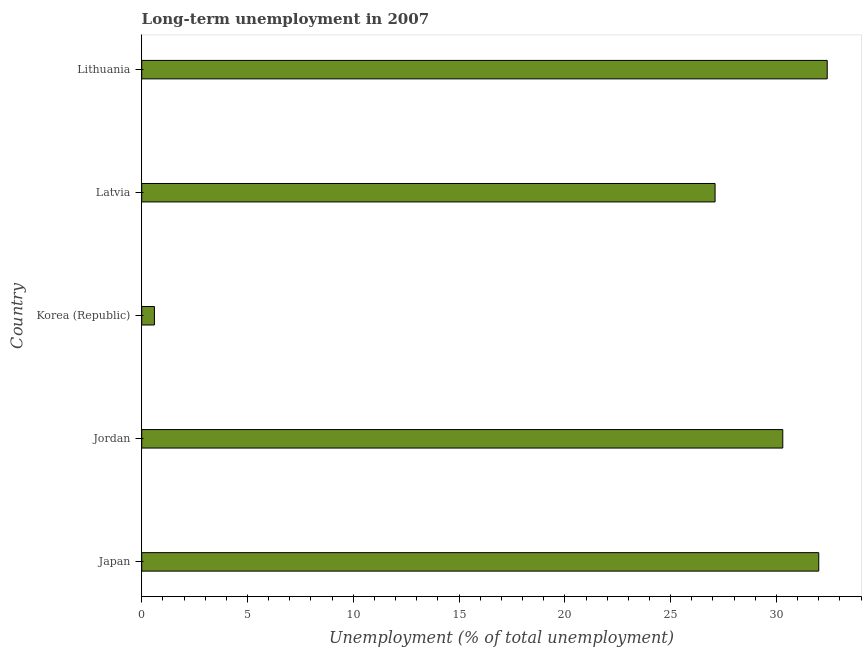Does the graph contain any zero values?
Offer a very short reply. No. Does the graph contain grids?
Ensure brevity in your answer.  No. What is the title of the graph?
Keep it short and to the point. Long-term unemployment in 2007. What is the label or title of the X-axis?
Give a very brief answer. Unemployment (% of total unemployment). What is the label or title of the Y-axis?
Your response must be concise. Country. What is the long-term unemployment in Lithuania?
Offer a terse response. 32.4. Across all countries, what is the maximum long-term unemployment?
Make the answer very short. 32.4. Across all countries, what is the minimum long-term unemployment?
Your answer should be very brief. 0.6. In which country was the long-term unemployment maximum?
Keep it short and to the point. Lithuania. In which country was the long-term unemployment minimum?
Provide a short and direct response. Korea (Republic). What is the sum of the long-term unemployment?
Provide a short and direct response. 122.4. What is the difference between the long-term unemployment in Jordan and Latvia?
Provide a short and direct response. 3.2. What is the average long-term unemployment per country?
Provide a short and direct response. 24.48. What is the median long-term unemployment?
Provide a short and direct response. 30.3. In how many countries, is the long-term unemployment greater than 31 %?
Your response must be concise. 2. What is the ratio of the long-term unemployment in Jordan to that in Latvia?
Give a very brief answer. 1.12. Is the difference between the long-term unemployment in Japan and Lithuania greater than the difference between any two countries?
Make the answer very short. No. Is the sum of the long-term unemployment in Japan and Lithuania greater than the maximum long-term unemployment across all countries?
Offer a very short reply. Yes. What is the difference between the highest and the lowest long-term unemployment?
Your answer should be very brief. 31.8. In how many countries, is the long-term unemployment greater than the average long-term unemployment taken over all countries?
Keep it short and to the point. 4. How many bars are there?
Make the answer very short. 5. Are the values on the major ticks of X-axis written in scientific E-notation?
Keep it short and to the point. No. What is the Unemployment (% of total unemployment) in Japan?
Make the answer very short. 32. What is the Unemployment (% of total unemployment) of Jordan?
Ensure brevity in your answer.  30.3. What is the Unemployment (% of total unemployment) in Korea (Republic)?
Give a very brief answer. 0.6. What is the Unemployment (% of total unemployment) in Latvia?
Offer a very short reply. 27.1. What is the Unemployment (% of total unemployment) in Lithuania?
Keep it short and to the point. 32.4. What is the difference between the Unemployment (% of total unemployment) in Japan and Jordan?
Your answer should be compact. 1.7. What is the difference between the Unemployment (% of total unemployment) in Japan and Korea (Republic)?
Your answer should be very brief. 31.4. What is the difference between the Unemployment (% of total unemployment) in Japan and Lithuania?
Offer a terse response. -0.4. What is the difference between the Unemployment (% of total unemployment) in Jordan and Korea (Republic)?
Your answer should be compact. 29.7. What is the difference between the Unemployment (% of total unemployment) in Jordan and Latvia?
Ensure brevity in your answer.  3.2. What is the difference between the Unemployment (% of total unemployment) in Korea (Republic) and Latvia?
Ensure brevity in your answer.  -26.5. What is the difference between the Unemployment (% of total unemployment) in Korea (Republic) and Lithuania?
Ensure brevity in your answer.  -31.8. What is the ratio of the Unemployment (% of total unemployment) in Japan to that in Jordan?
Offer a very short reply. 1.06. What is the ratio of the Unemployment (% of total unemployment) in Japan to that in Korea (Republic)?
Make the answer very short. 53.33. What is the ratio of the Unemployment (% of total unemployment) in Japan to that in Latvia?
Your answer should be very brief. 1.18. What is the ratio of the Unemployment (% of total unemployment) in Jordan to that in Korea (Republic)?
Offer a very short reply. 50.5. What is the ratio of the Unemployment (% of total unemployment) in Jordan to that in Latvia?
Your answer should be very brief. 1.12. What is the ratio of the Unemployment (% of total unemployment) in Jordan to that in Lithuania?
Provide a succinct answer. 0.94. What is the ratio of the Unemployment (% of total unemployment) in Korea (Republic) to that in Latvia?
Give a very brief answer. 0.02. What is the ratio of the Unemployment (% of total unemployment) in Korea (Republic) to that in Lithuania?
Your answer should be very brief. 0.02. What is the ratio of the Unemployment (% of total unemployment) in Latvia to that in Lithuania?
Provide a succinct answer. 0.84. 